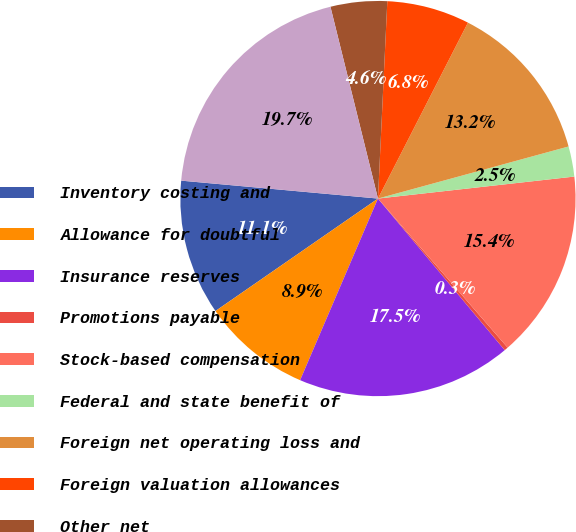<chart> <loc_0><loc_0><loc_500><loc_500><pie_chart><fcel>Inventory costing and<fcel>Allowance for doubtful<fcel>Insurance reserves<fcel>Promotions payable<fcel>Stock-based compensation<fcel>Federal and state benefit of<fcel>Foreign net operating loss and<fcel>Foreign valuation allowances<fcel>Other net<fcel>Total deferred income tax<nl><fcel>11.08%<fcel>8.92%<fcel>17.53%<fcel>0.31%<fcel>15.38%<fcel>2.47%<fcel>13.23%<fcel>6.77%<fcel>4.62%<fcel>19.69%<nl></chart> 